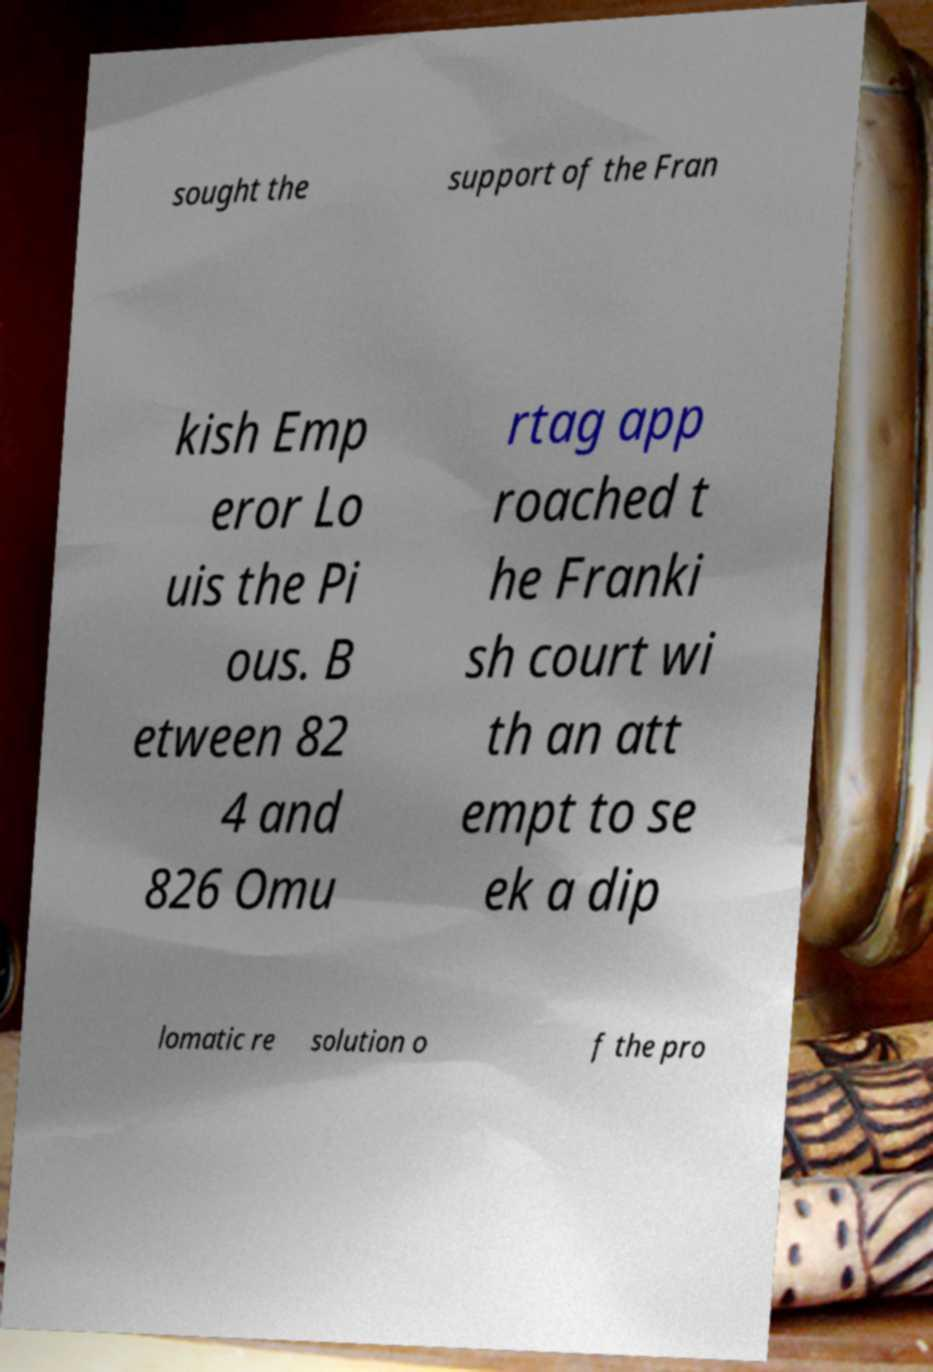Could you extract and type out the text from this image? sought the support of the Fran kish Emp eror Lo uis the Pi ous. B etween 82 4 and 826 Omu rtag app roached t he Franki sh court wi th an att empt to se ek a dip lomatic re solution o f the pro 